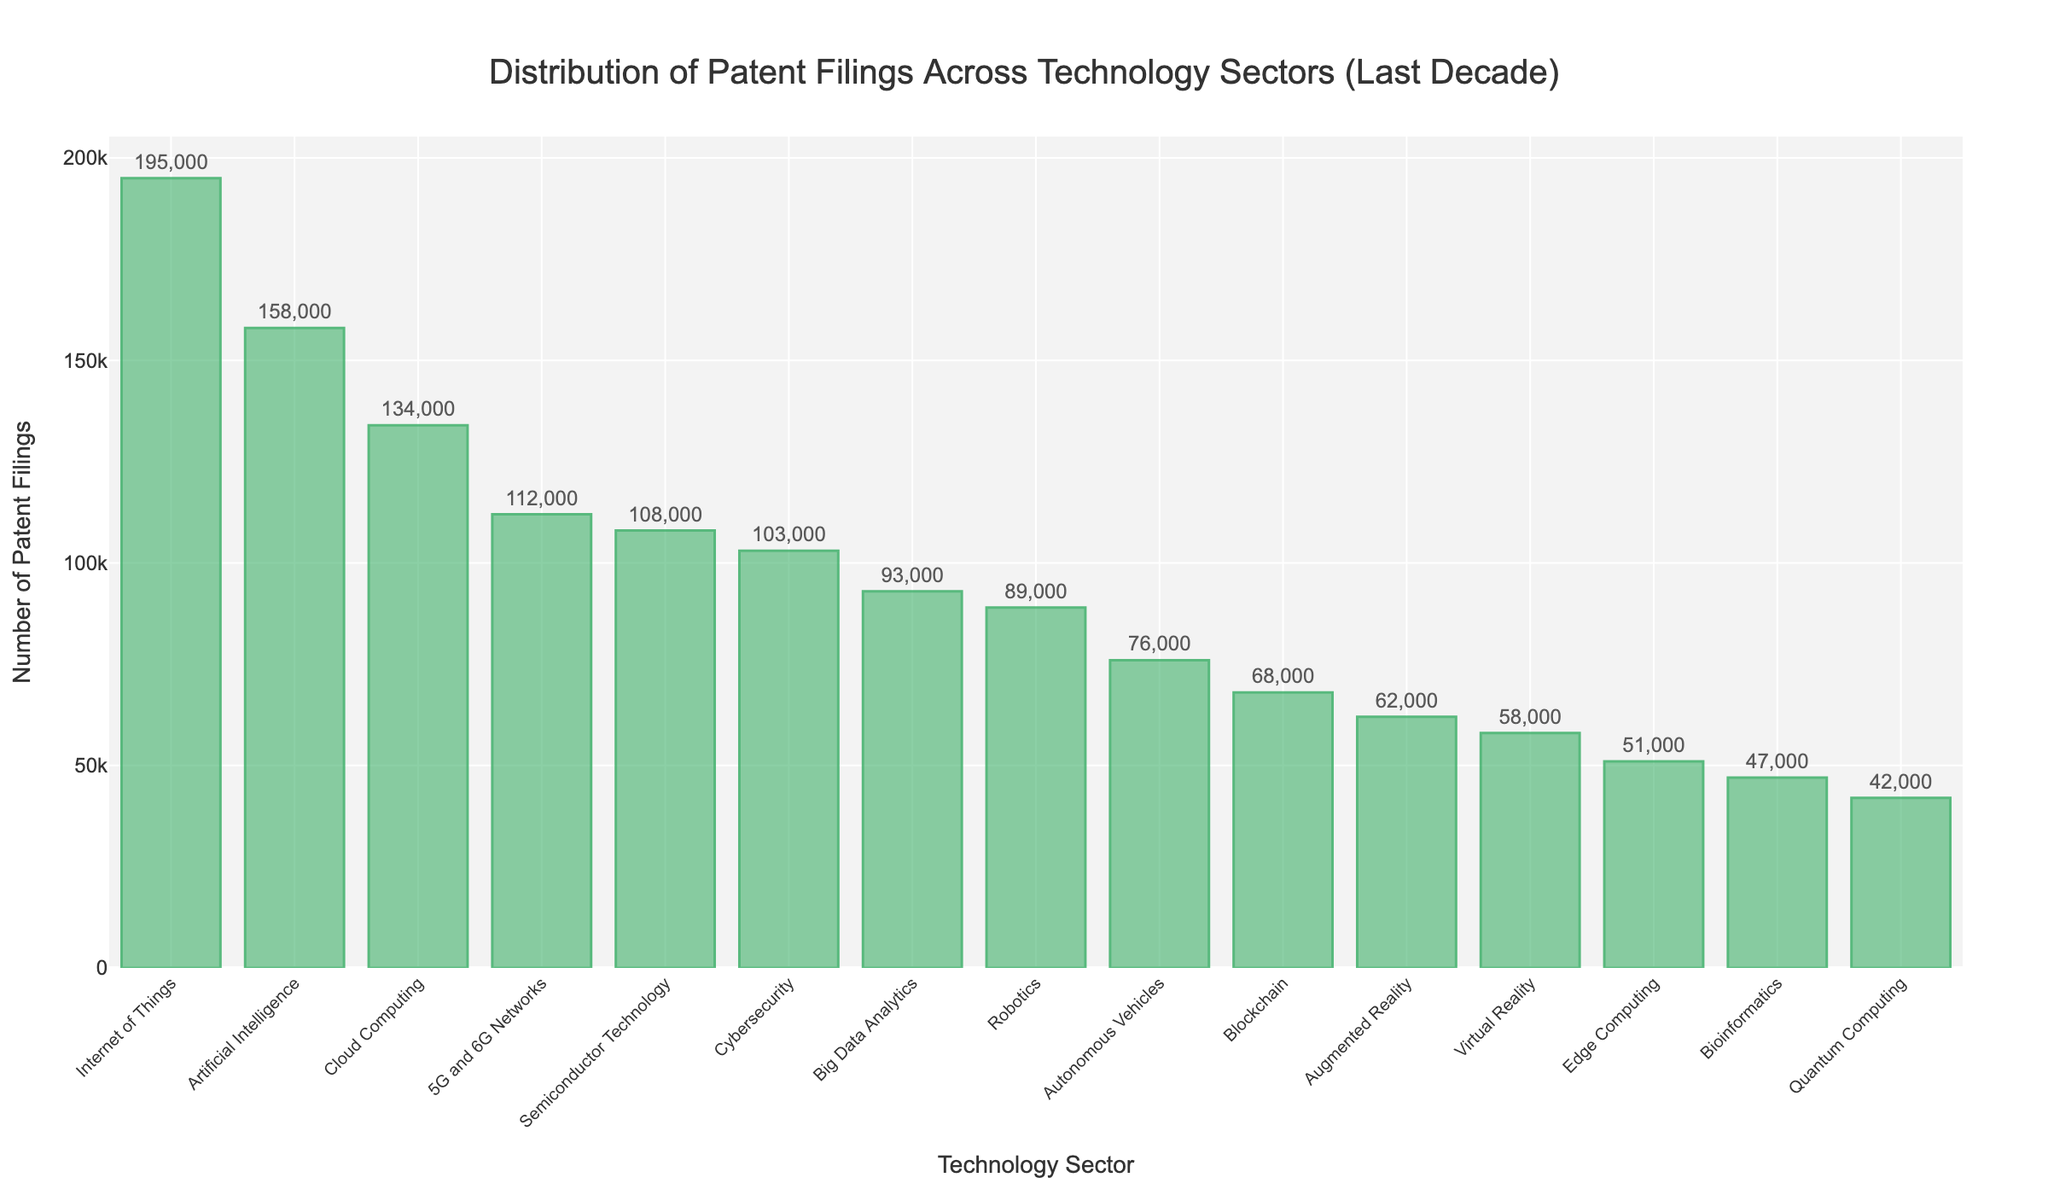What's the technology sector with the highest number of patent filings? The technology sector with the highest number of patent filings is represented by the tallest bar in the bar chart. This bar belongs to the "Internet of Things" sector.
Answer: Internet of Things What's the difference in patent filings between the sector with the most filings and the sector with the least filings? To find this, locate the sector with the most filings ("Internet of Things" with 195,000 filings) and the one with the least filings ("Quantum Computing" with 42,000 filings). Subtract the latter from the former: 195,000 - 42,000 = 153,000.
Answer: 153,000 Which technology sector has fewer patent filings: Cybersecurity or Robotics? Compare the heights of the bars for "Cybersecurity" and "Robotics". The bar for "Robotics" is shorter with 89,000 filings, whereas "Cybersecurity" has 103,000 filings.
Answer: Robotics What's the average number of patent filings for the top three sectors with the most filings? Identify the top three sectors: "Internet of Things" (195,000), "Artificial Intelligence" (158,000), and "Cloud Computing" (134,000). Sum these values: 195,000 + 158,000 + 134,000 = 487,000. Divide by 3 to find the average: 487,000 / 3 ≈ 162,333.
Answer: 162,333 How many sectors have patent filings greater than 100,000? Count the bars with their values greater than 100,000. From the chart, these sectors are "Internet of Things", "Artificial Intelligence", "Cloud Computing", "5G and 6G Networks", "Cybersecurity", and "Semiconductor Technology", making a total of 6 sectors.
Answer: 6 Which sector has more patent filings: Blockchain or Edge Computing, and by how much? Compare the heights of the bars for "Blockchain" (68,000) and "Edge Computing" (51,000). Blockchain has more filings. Calculate the difference: 68,000 - 51,000 = 17,000.
Answer: Blockchain, 17,000 Is the number of patent filings in Autonomous Vehicles closer to Augmented Reality or Virtual Reality? Check the filings for "Autonomous Vehicles" (76,000), "Augmented Reality" (62,000), and "Virtual Reality" (58,000). Calculate the differences: 76,000 - 62,000 = 14,000 and 76,000 - 58,000 = 18,000. Since 14,000 < 18,000, it is closer to "Augmented Reality".
Answer: Augmented Reality Is the sum of patent filings for Quantum Computing, Blockchain, and Edge Computing greater than that of Artificial Intelligence? Sum the filings for "Quantum Computing" (42,000), "Blockchain" (68,000), and "Edge Computing" (51,000): 42,000 + 68,000 + 51,000 = 161,000. Compare this with "Artificial Intelligence" (158,000). Since 161,000 > 158,000, the sum is greater.
Answer: Yes What is the median number of patent filings across all sectors? Arrange the numbers in ascending order and find the middle value(s). The order is: 42,000, 47,000, 51,000, 58,000, 62,000, 68,000, 76,000, 89,000, 93,000, 103,000, 108,000, 112,000, 134,000, 158,000, 195,000. The median (8th value) is 76,000.
Answer: 76,000 